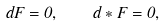Convert formula to latex. <formula><loc_0><loc_0><loc_500><loc_500>d F = 0 , \quad d * F = 0 ,</formula> 